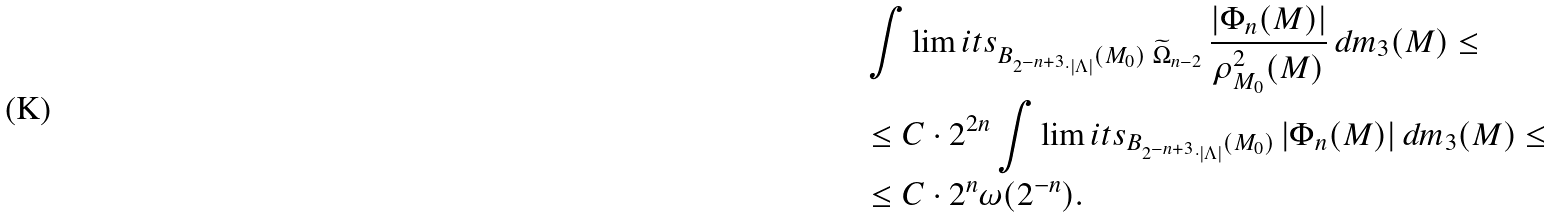<formula> <loc_0><loc_0><loc_500><loc_500>& \int \lim i t s _ { B _ { 2 ^ { - n + 3 } \cdot | \Lambda | } ( M _ { 0 } ) \ \widetilde { \Omega } _ { n - 2 } } \, \frac { | \Phi _ { n } ( M ) | } { \rho ^ { 2 } _ { M _ { 0 } } ( M ) } \, d m _ { 3 } ( M ) \leq \\ & \leq C \cdot 2 ^ { 2 n } \int \lim i t s _ { B _ { 2 ^ { - n + 3 } \cdot | \Lambda | } ( M _ { 0 } ) } \, | \Phi _ { n } ( M ) | \, d m _ { 3 } ( M ) \leq \\ & \leq C \cdot 2 ^ { n } \omega ( 2 ^ { - n } ) .</formula> 